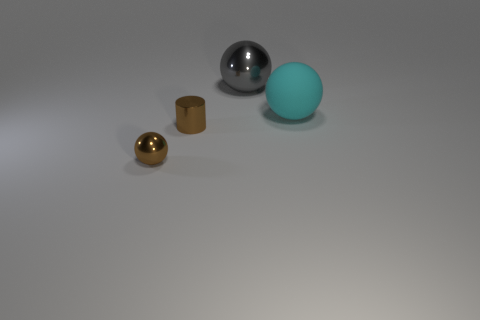There is a tiny cylinder that is the same color as the tiny metal ball; what is its material?
Make the answer very short. Metal. There is a ball that is the same size as the cylinder; what is its material?
Provide a succinct answer. Metal. What number of other objects are there of the same color as the large metal sphere?
Provide a short and direct response. 0. There is a shiny ball right of the small brown shiny cylinder; is it the same size as the brown shiny object that is to the right of the brown metallic sphere?
Provide a succinct answer. No. Are there the same number of tiny cylinders that are behind the gray metal object and objects that are behind the big cyan ball?
Keep it short and to the point. No. Is there any other thing that is made of the same material as the cyan thing?
Give a very brief answer. No. Is the size of the cyan ball the same as the sphere that is in front of the cyan matte ball?
Offer a terse response. No. The ball that is left of the large thing that is left of the cyan matte thing is made of what material?
Your response must be concise. Metal. Are there the same number of tiny brown objects in front of the brown metallic ball and green matte cubes?
Give a very brief answer. Yes. What size is the sphere that is in front of the gray ball and on the left side of the big cyan rubber sphere?
Give a very brief answer. Small. 